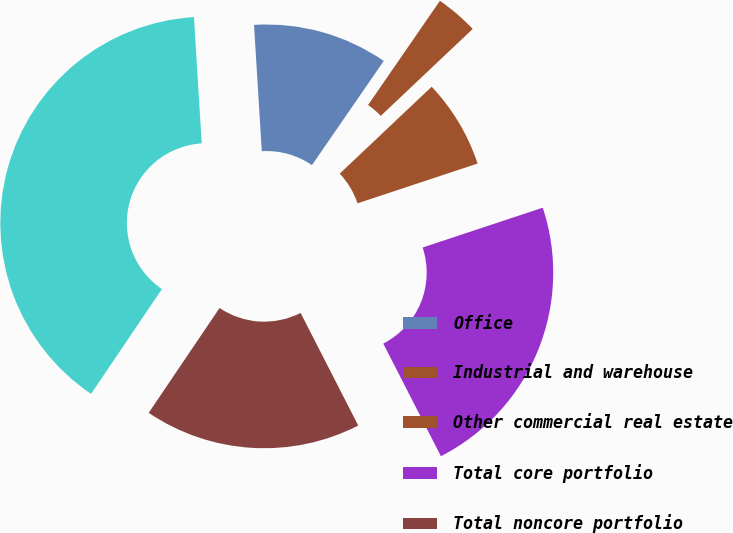Convert chart to OTSL. <chart><loc_0><loc_0><loc_500><loc_500><pie_chart><fcel>Office<fcel>Industrial and warehouse<fcel>Other commercial real estate<fcel>Total core portfolio<fcel>Total noncore portfolio<fcel>Total<nl><fcel>10.58%<fcel>3.34%<fcel>6.96%<fcel>22.56%<fcel>16.99%<fcel>39.56%<nl></chart> 